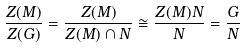<formula> <loc_0><loc_0><loc_500><loc_500>\frac { Z ( M ) } { Z ( G ) } = \frac { Z ( M ) } { Z ( M ) \cap N } \cong \frac { Z ( M ) N } { N } = \frac { G } { N }</formula> 